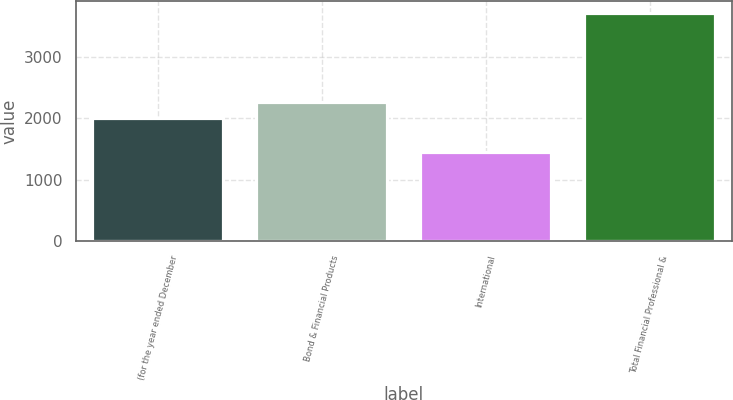Convert chart. <chart><loc_0><loc_0><loc_500><loc_500><bar_chart><fcel>(for the year ended December<fcel>Bond & Financial Products<fcel>International<fcel>Total Financial Professional &<nl><fcel>2009<fcel>2262<fcel>1451<fcel>3713<nl></chart> 